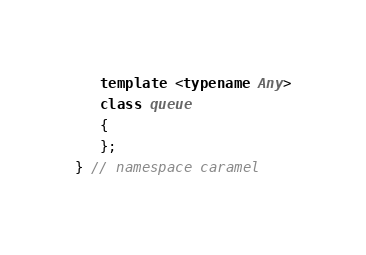Convert code to text. <code><loc_0><loc_0><loc_500><loc_500><_C++_>   template <typename Any>
   class queue
   {
   };
} // namespace caramel
</code> 